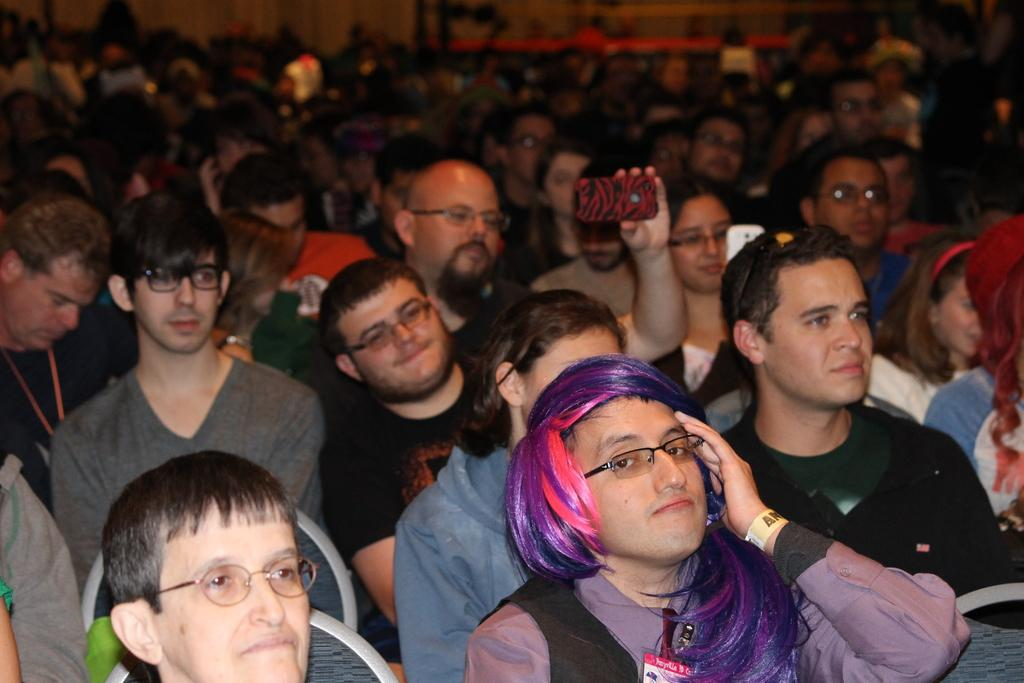How many people are in the image? There is a group of people in the image. What is the man in the image doing? The man is sitting and holding a device. What can be seen in the background of the image? There is a wall visible in the background of the image. What color is the cherry on the hydrant in the image? There is no hydrant or cherry present in the image. Can you describe the stranger in the image? There is no stranger present in the image; the people in the image are part of a group. 